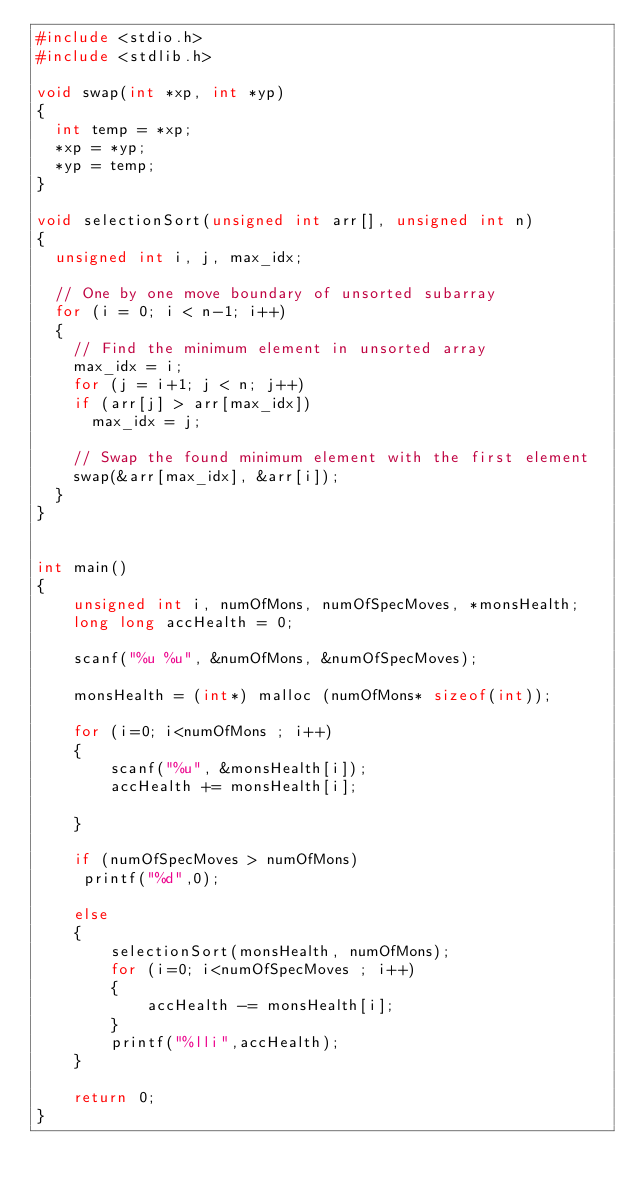Convert code to text. <code><loc_0><loc_0><loc_500><loc_500><_C_>#include <stdio.h>
#include <stdlib.h>

void swap(int *xp, int *yp) 
{ 
	int temp = *xp; 
	*xp = *yp; 
	*yp = temp; 
} 

void selectionSort(unsigned int arr[], unsigned int n) 
{ 
	unsigned int i, j, max_idx; 

	// One by one move boundary of unsorted subarray 
	for (i = 0; i < n-1; i++) 
	{ 
		// Find the minimum element in unsorted array 
		max_idx = i; 
		for (j = i+1; j < n; j++) 
		if (arr[j] > arr[max_idx]) 
			max_idx = j; 

		// Swap the found minimum element with the first element 
		swap(&arr[max_idx], &arr[i]); 
	} 
} 


int main()
{
    unsigned int i, numOfMons, numOfSpecMoves, *monsHealth; 
    long long accHealth = 0;
    
    scanf("%u %u", &numOfMons, &numOfSpecMoves);

    monsHealth = (int*) malloc (numOfMons* sizeof(int));
    
    for (i=0; i<numOfMons ; i++)
    {
        scanf("%u", &monsHealth[i]);
        accHealth += monsHealth[i];

    }
    
    if (numOfSpecMoves > numOfMons) 
     printf("%d",0);
     
    else
    {
        selectionSort(monsHealth, numOfMons); 
        for (i=0; i<numOfSpecMoves ; i++)
        {
            accHealth -= monsHealth[i];
        }
        printf("%lli",accHealth);
    }

    return 0;
}</code> 